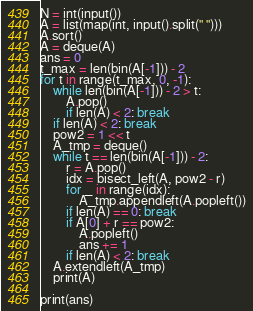Convert code to text. <code><loc_0><loc_0><loc_500><loc_500><_Python_>N = int(input())
A = list(map(int, input().split(" ")))
A.sort()
A = deque(A)
ans = 0
t_max = len(bin(A[-1])) - 2
for t in range(t_max, 0, -1):
    while len(bin(A[-1])) - 2 > t:
        A.pop()
        if len(A) < 2: break
    if len(A) < 2: break
    pow2 = 1 << t
    A_tmp = deque()
    while t == len(bin(A[-1])) - 2:
        r = A.pop()
        idx = bisect_left(A, pow2 - r)
        for _ in range(idx):
            A_tmp.appendleft(A.popleft())
        if len(A) == 0: break
        if A[0] + r == pow2:
            A.popleft()
            ans += 1
        if len(A) < 2: break
    A.extendleft(A_tmp)
    print(A)
                    
print(ans)</code> 